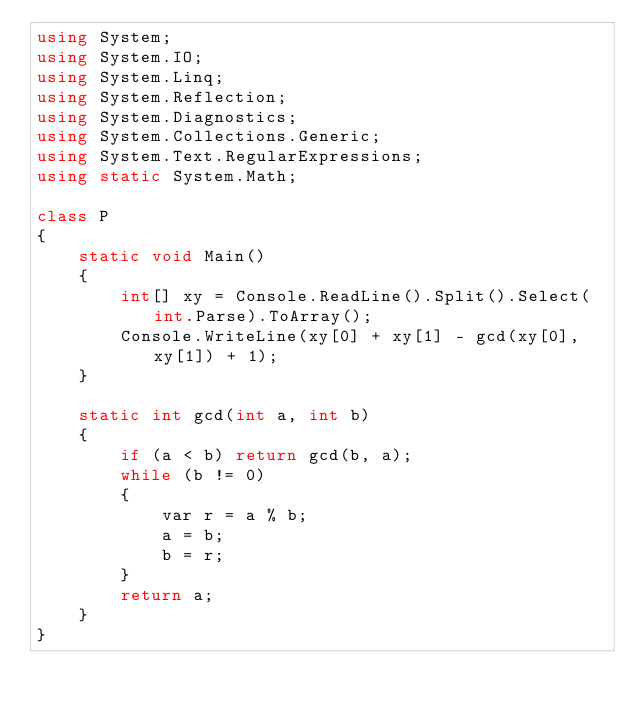Convert code to text. <code><loc_0><loc_0><loc_500><loc_500><_C#_>using System;
using System.IO;
using System.Linq;
using System.Reflection;
using System.Diagnostics;
using System.Collections.Generic;
using System.Text.RegularExpressions;
using static System.Math;

class P
{
    static void Main()
    {
        int[] xy = Console.ReadLine().Split().Select(int.Parse).ToArray();
        Console.WriteLine(xy[0] + xy[1] - gcd(xy[0], xy[1]) + 1);
    }

    static int gcd(int a, int b)
    {
        if (a < b) return gcd(b, a);
        while (b != 0)
        {
            var r = a % b;
            a = b;
            b = r;
        }
        return a;
    }
}
</code> 